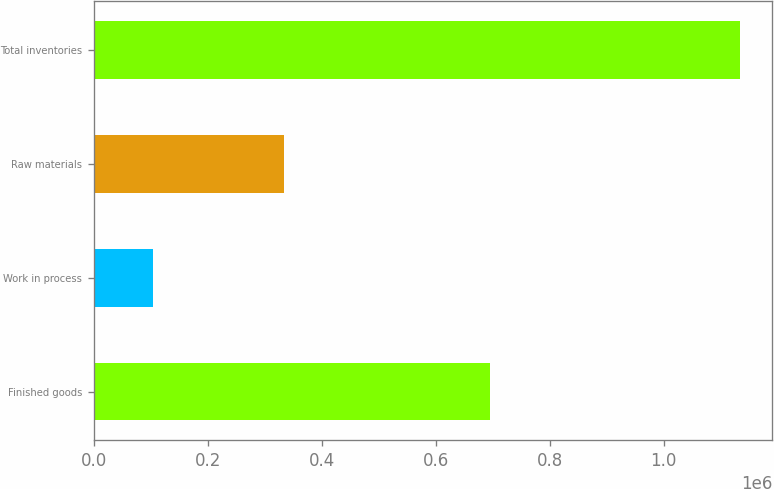Convert chart to OTSL. <chart><loc_0><loc_0><loc_500><loc_500><bar_chart><fcel>Finished goods<fcel>Work in process<fcel>Raw materials<fcel>Total inventories<nl><fcel>695606<fcel>103685<fcel>334445<fcel>1.13374e+06<nl></chart> 